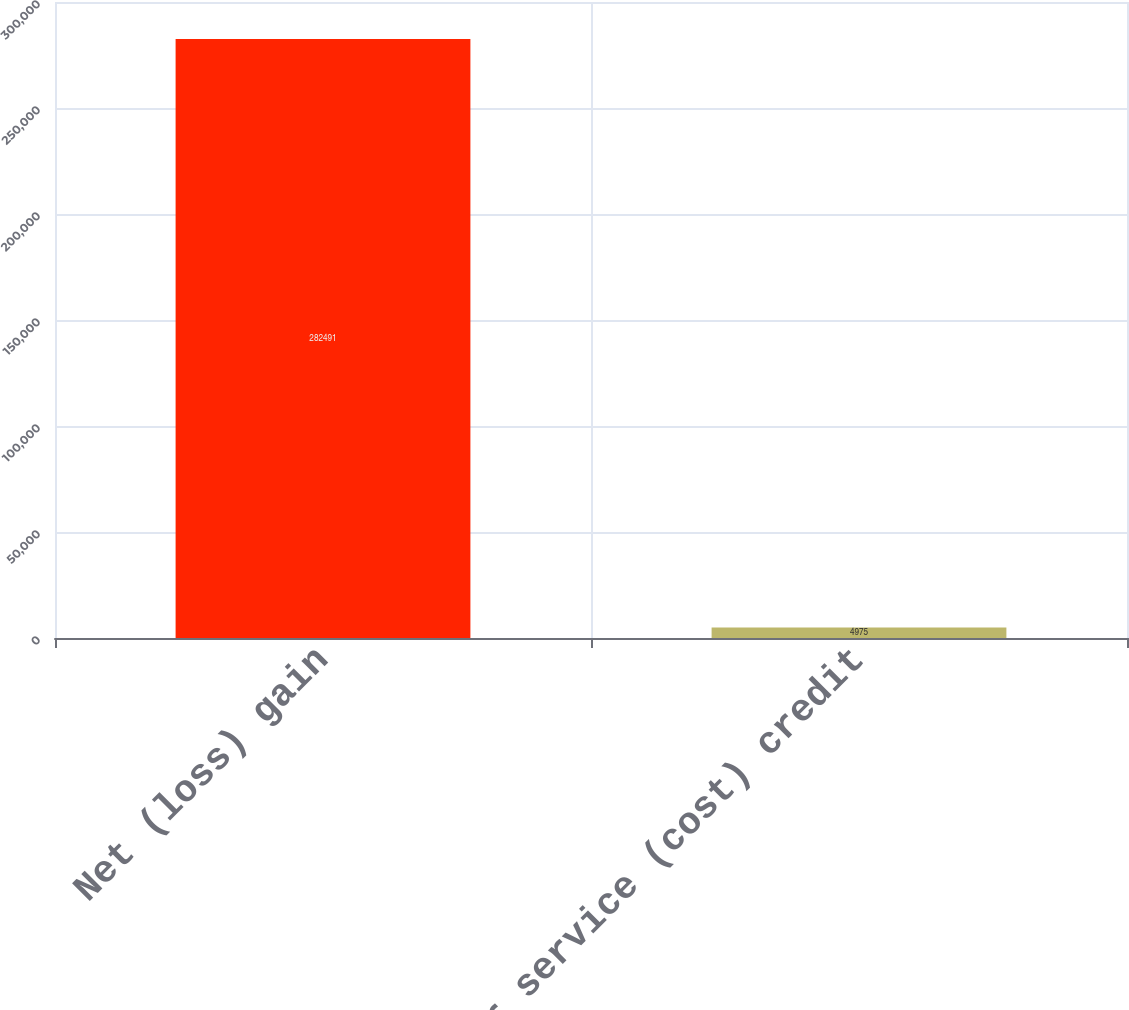Convert chart. <chart><loc_0><loc_0><loc_500><loc_500><bar_chart><fcel>Net (loss) gain<fcel>Prior service (cost) credit<nl><fcel>282491<fcel>4975<nl></chart> 